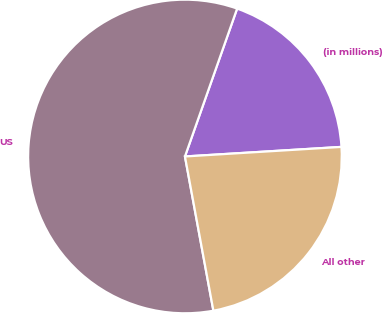<chart> <loc_0><loc_0><loc_500><loc_500><pie_chart><fcel>(in millions)<fcel>US<fcel>All other<nl><fcel>18.63%<fcel>58.3%<fcel>23.07%<nl></chart> 